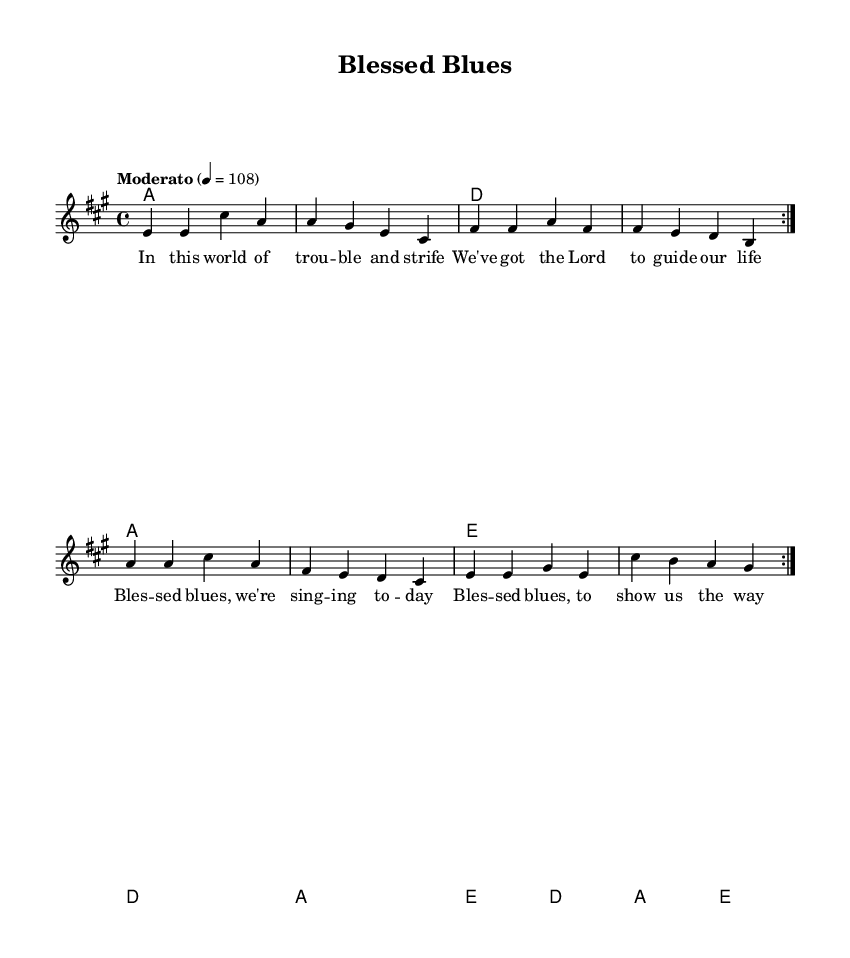What is the key signature of this music? The key signature is A major, which is indicated by three sharps (F#, C#, and G#) in the key signature at the beginning of the staff.
Answer: A major What is the time signature of this music? The time signature is 4/4, indicated by the "4/4" noted at the beginning of the staff. This means there are four beats in each measure, and the quarter note receives one beat.
Answer: 4/4 What is the tempo marking of this piece? The tempo marking states "Moderato" and indicates a metronome marking of 108 beats per minute, which can be observed under the global settings at the beginning of the score.
Answer: Moderato 4 = 108 How many measures are there in the repeated volta section? The repeated section, marked with "volta", consists of 8 measures as it goes through the melody and harmonies two times. Counting each measure in the repeated section confirms that there are a total of 8.
Answer: 8 What is the first lyric line of the song? The first line of the lyrics states "In this world of trouble and strife," which can be found at the beginning of the lyrics section aligned with the melody notes.
Answer: In this world of trouble and strife What chord is played during the first measure? The first measure features the A major chord, shown in the chord symbols underneath the melody at the start of the piece.
Answer: A How does the structure of this piece reflect traditional electric blues? The structure includes a typical 12-bar blues progression with a repeated volta, emphasizing themes of life's challenges and spiritual guidance reflective of traditional electric blues music. This can be identified by analyzing the melody and harmony patterns, which follow common electric blues forms.
Answer: 12-bar blues 